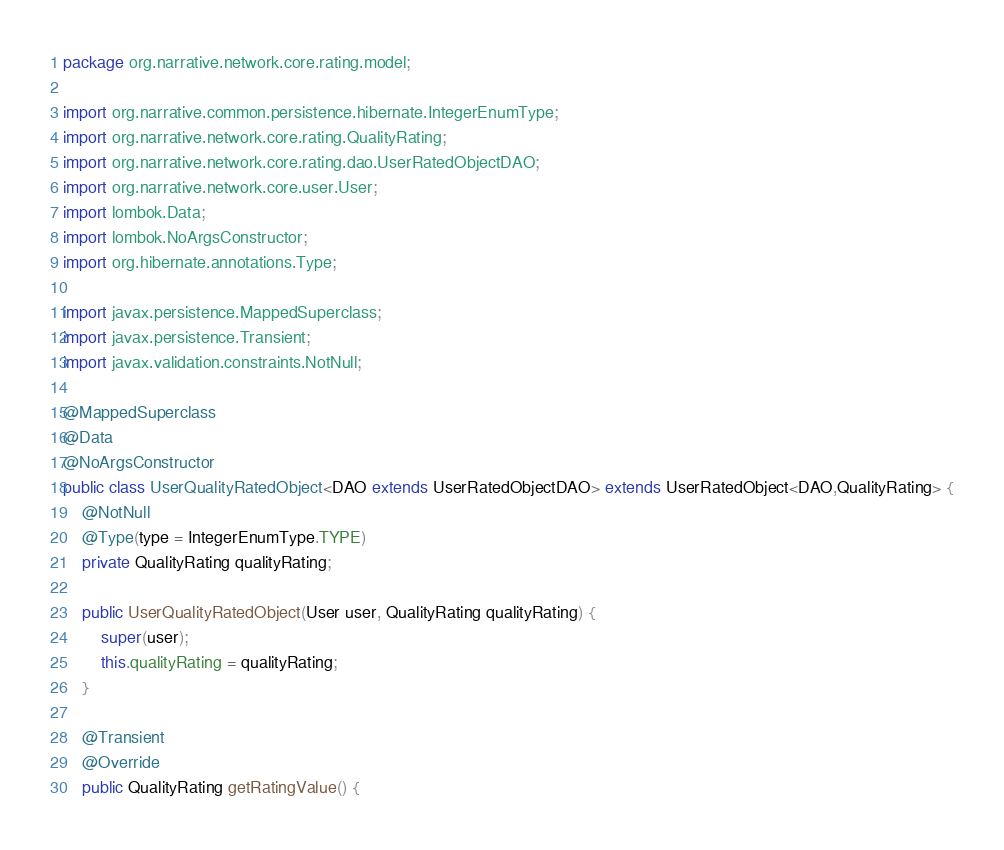<code> <loc_0><loc_0><loc_500><loc_500><_Java_>package org.narrative.network.core.rating.model;

import org.narrative.common.persistence.hibernate.IntegerEnumType;
import org.narrative.network.core.rating.QualityRating;
import org.narrative.network.core.rating.dao.UserRatedObjectDAO;
import org.narrative.network.core.user.User;
import lombok.Data;
import lombok.NoArgsConstructor;
import org.hibernate.annotations.Type;

import javax.persistence.MappedSuperclass;
import javax.persistence.Transient;
import javax.validation.constraints.NotNull;

@MappedSuperclass
@Data
@NoArgsConstructor
public class UserQualityRatedObject<DAO extends UserRatedObjectDAO> extends UserRatedObject<DAO,QualityRating> {
    @NotNull
    @Type(type = IntegerEnumType.TYPE)
    private QualityRating qualityRating;

    public UserQualityRatedObject(User user, QualityRating qualityRating) {
        super(user);
        this.qualityRating = qualityRating;
    }

    @Transient
    @Override
    public QualityRating getRatingValue() {</code> 